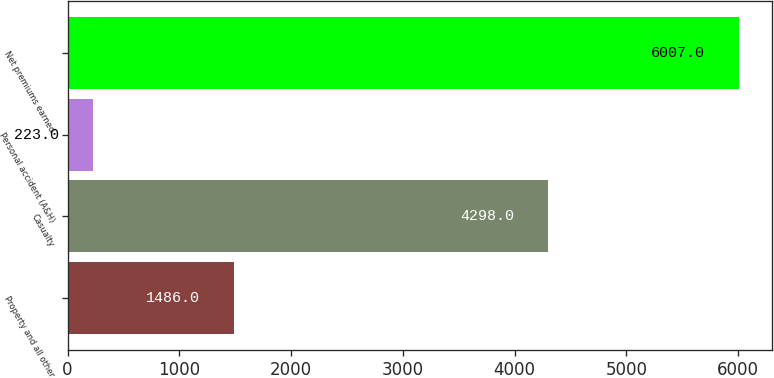Convert chart to OTSL. <chart><loc_0><loc_0><loc_500><loc_500><bar_chart><fcel>Property and all other<fcel>Casualty<fcel>Personal accident (A&H)<fcel>Net premiums earned<nl><fcel>1486<fcel>4298<fcel>223<fcel>6007<nl></chart> 